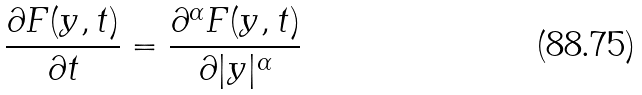<formula> <loc_0><loc_0><loc_500><loc_500>\frac { \partial F ( y , t ) } { \partial t } = \frac { \partial ^ { \alpha } F ( y , t ) } { \partial | y | ^ { \alpha } }</formula> 